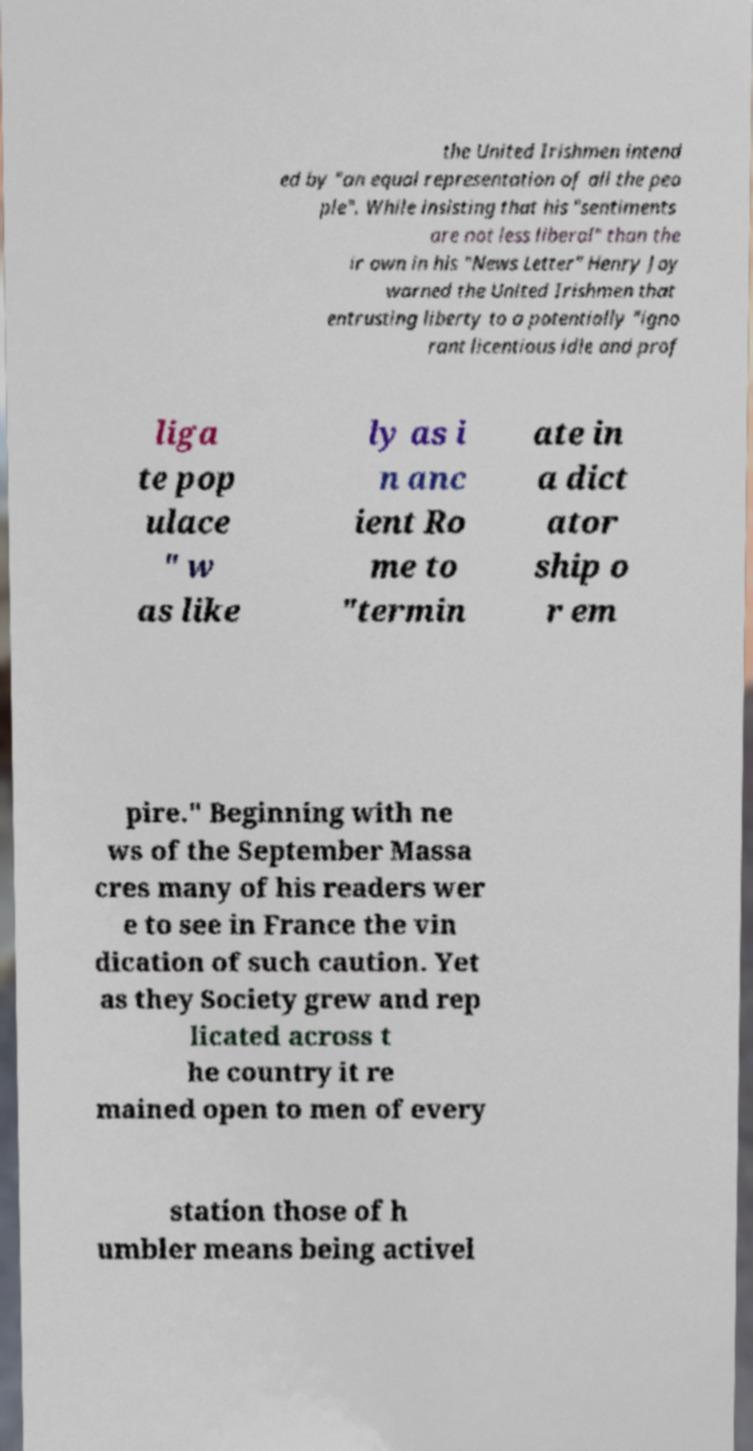What messages or text are displayed in this image? I need them in a readable, typed format. the United Irishmen intend ed by "an equal representation of all the peo ple". While insisting that his "sentiments are not less liberal" than the ir own in his "News Letter" Henry Joy warned the United Irishmen that entrusting liberty to a potentially "igno rant licentious idle and prof liga te pop ulace " w as like ly as i n anc ient Ro me to "termin ate in a dict ator ship o r em pire." Beginning with ne ws of the September Massa cres many of his readers wer e to see in France the vin dication of such caution. Yet as they Society grew and rep licated across t he country it re mained open to men of every station those of h umbler means being activel 